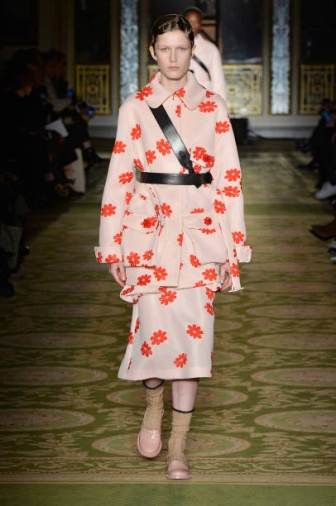If you could give the model any prop to enhance the outfit, what would it be? To enhance the outfit, I would suggest a delicate, oversized floral hat that matches the red flowers on the dress. This hat could add a touch of classic elegance and make the ensemble even more captivating, drawing attention to the model's face and adding height to the overall look. 